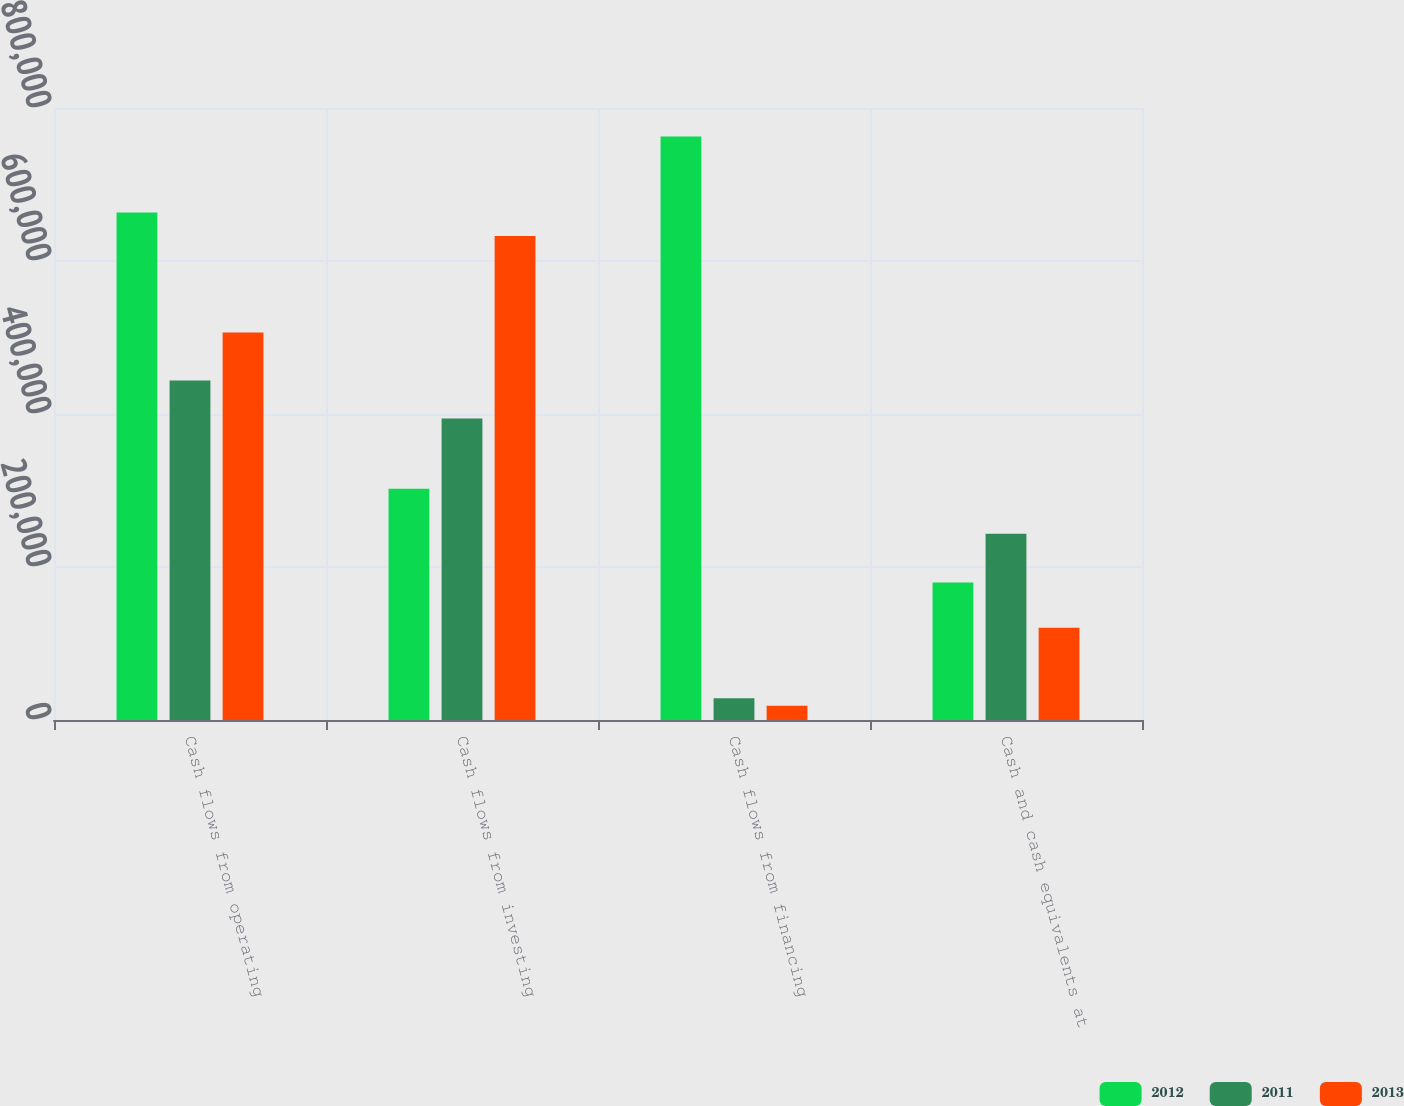Convert chart. <chart><loc_0><loc_0><loc_500><loc_500><stacked_bar_chart><ecel><fcel>Cash flows from operating<fcel>Cash flows from investing<fcel>Cash flows from financing<fcel>Cash and cash equivalents at<nl><fcel>2012<fcel>663514<fcel>302213<fcel>762670<fcel>179845<nl><fcel>2011<fcel>443652<fcel>394064<fcel>28269<fcel>243415<nl><fcel>2013<fcel>506593<fcel>632750<fcel>18564<fcel>120526<nl></chart> 